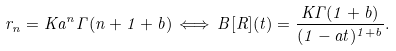Convert formula to latex. <formula><loc_0><loc_0><loc_500><loc_500>r _ { n } = K a ^ { n } \Gamma ( n + 1 + b ) \, \Longleftrightarrow \, B [ R ] ( t ) = \frac { K \Gamma ( 1 + b ) } { ( 1 - a t ) ^ { 1 + b } } .</formula> 